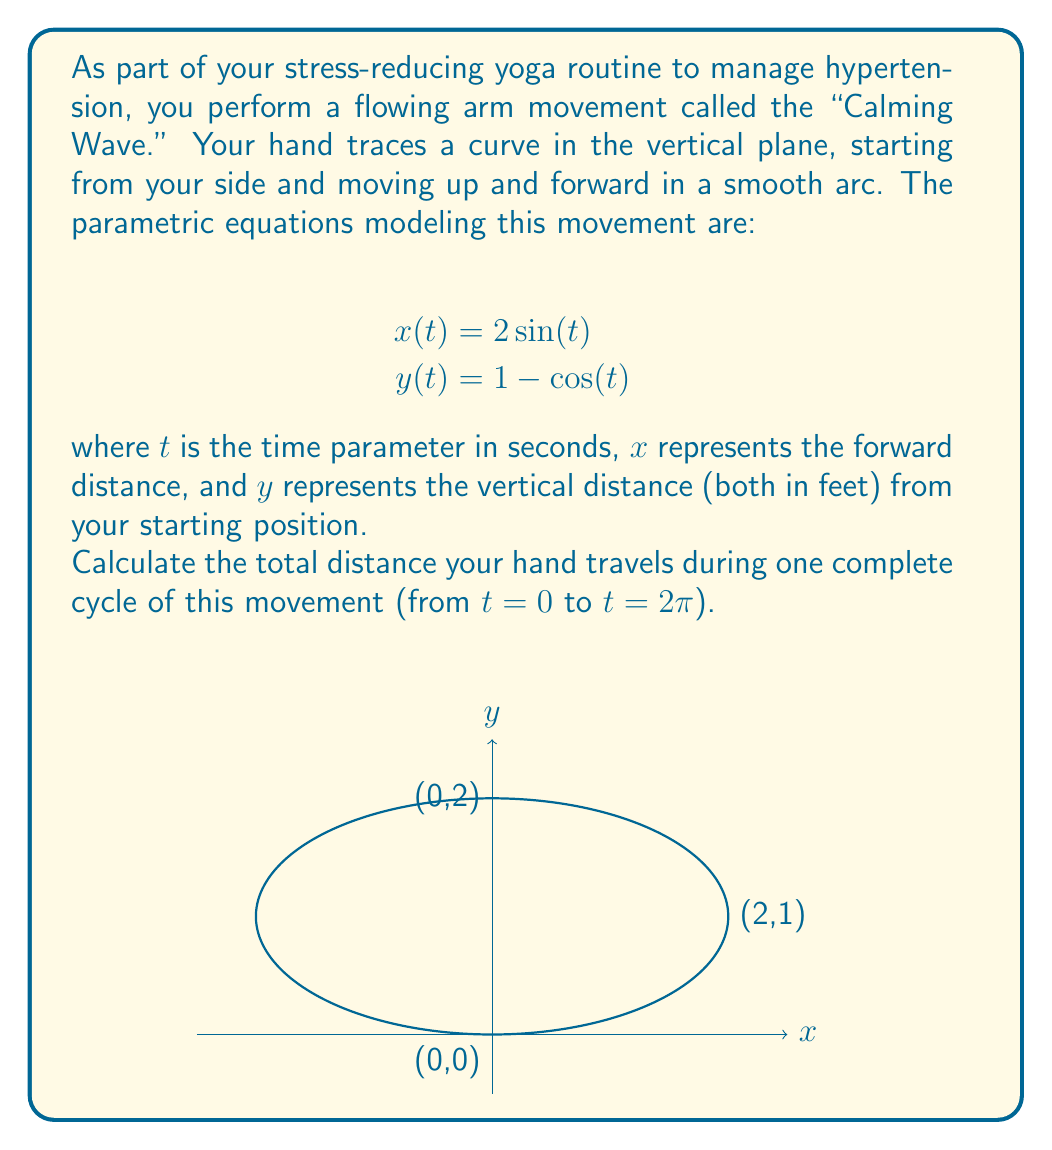Help me with this question. To find the total distance traveled, we need to calculate the arc length of the parametric curve over the given interval. The formula for arc length of a parametric curve is:

$$L = \int_a^b \sqrt{\left(\frac{dx}{dt}\right)^2 + \left(\frac{dy}{dt}\right)^2} dt$$

Step 1: Find the derivatives $\frac{dx}{dt}$ and $\frac{dy}{dt}$
$$\frac{dx}{dt} = 2\cos(t)$$
$$\frac{dy}{dt} = \sin(t)$$

Step 2: Substitute these into the arc length formula
$$L = \int_0^{2\pi} \sqrt{(2\cos(t))^2 + (\sin(t))^2} dt$$

Step 3: Simplify the expression under the square root
$$L = \int_0^{2\pi} \sqrt{4\cos^2(t) + \sin^2(t)} dt$$

Step 4: Use the trigonometric identity $\cos^2(t) + \sin^2(t) = 1$
$$L = \int_0^{2\pi} \sqrt{4(1-\sin^2(t)) + \sin^2(t)} dt$$
$$L = \int_0^{2\pi} \sqrt{4 - 3\sin^2(t)} dt$$

Step 5: This integral doesn't have an elementary antiderivative, so we need to use numerical integration. Using a computer algebra system or calculator, we can evaluate this definite integral:

$$L \approx 7.64 \text{ feet}$$

This result represents the total distance your hand travels during one complete cycle of the "Calming Wave" movement.
Answer: $7.64 \text{ feet}$ 